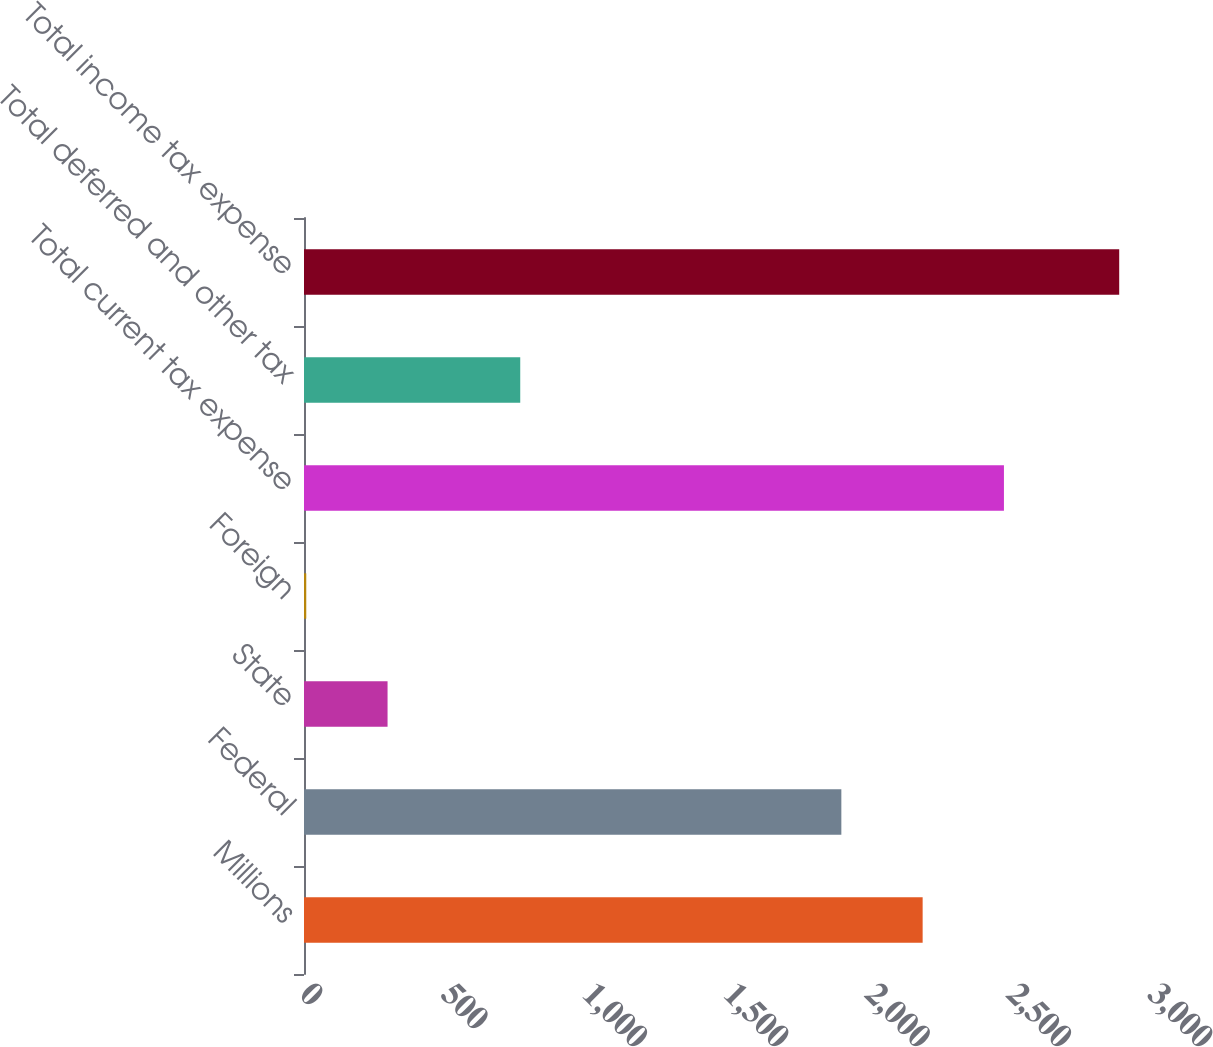Convert chart to OTSL. <chart><loc_0><loc_0><loc_500><loc_500><bar_chart><fcel>Millions<fcel>Federal<fcel>State<fcel>Foreign<fcel>Total current tax expense<fcel>Total deferred and other tax<fcel>Total income tax expense<nl><fcel>2188.6<fcel>1901<fcel>295.6<fcel>8<fcel>2476.2<fcel>765<fcel>2884<nl></chart> 